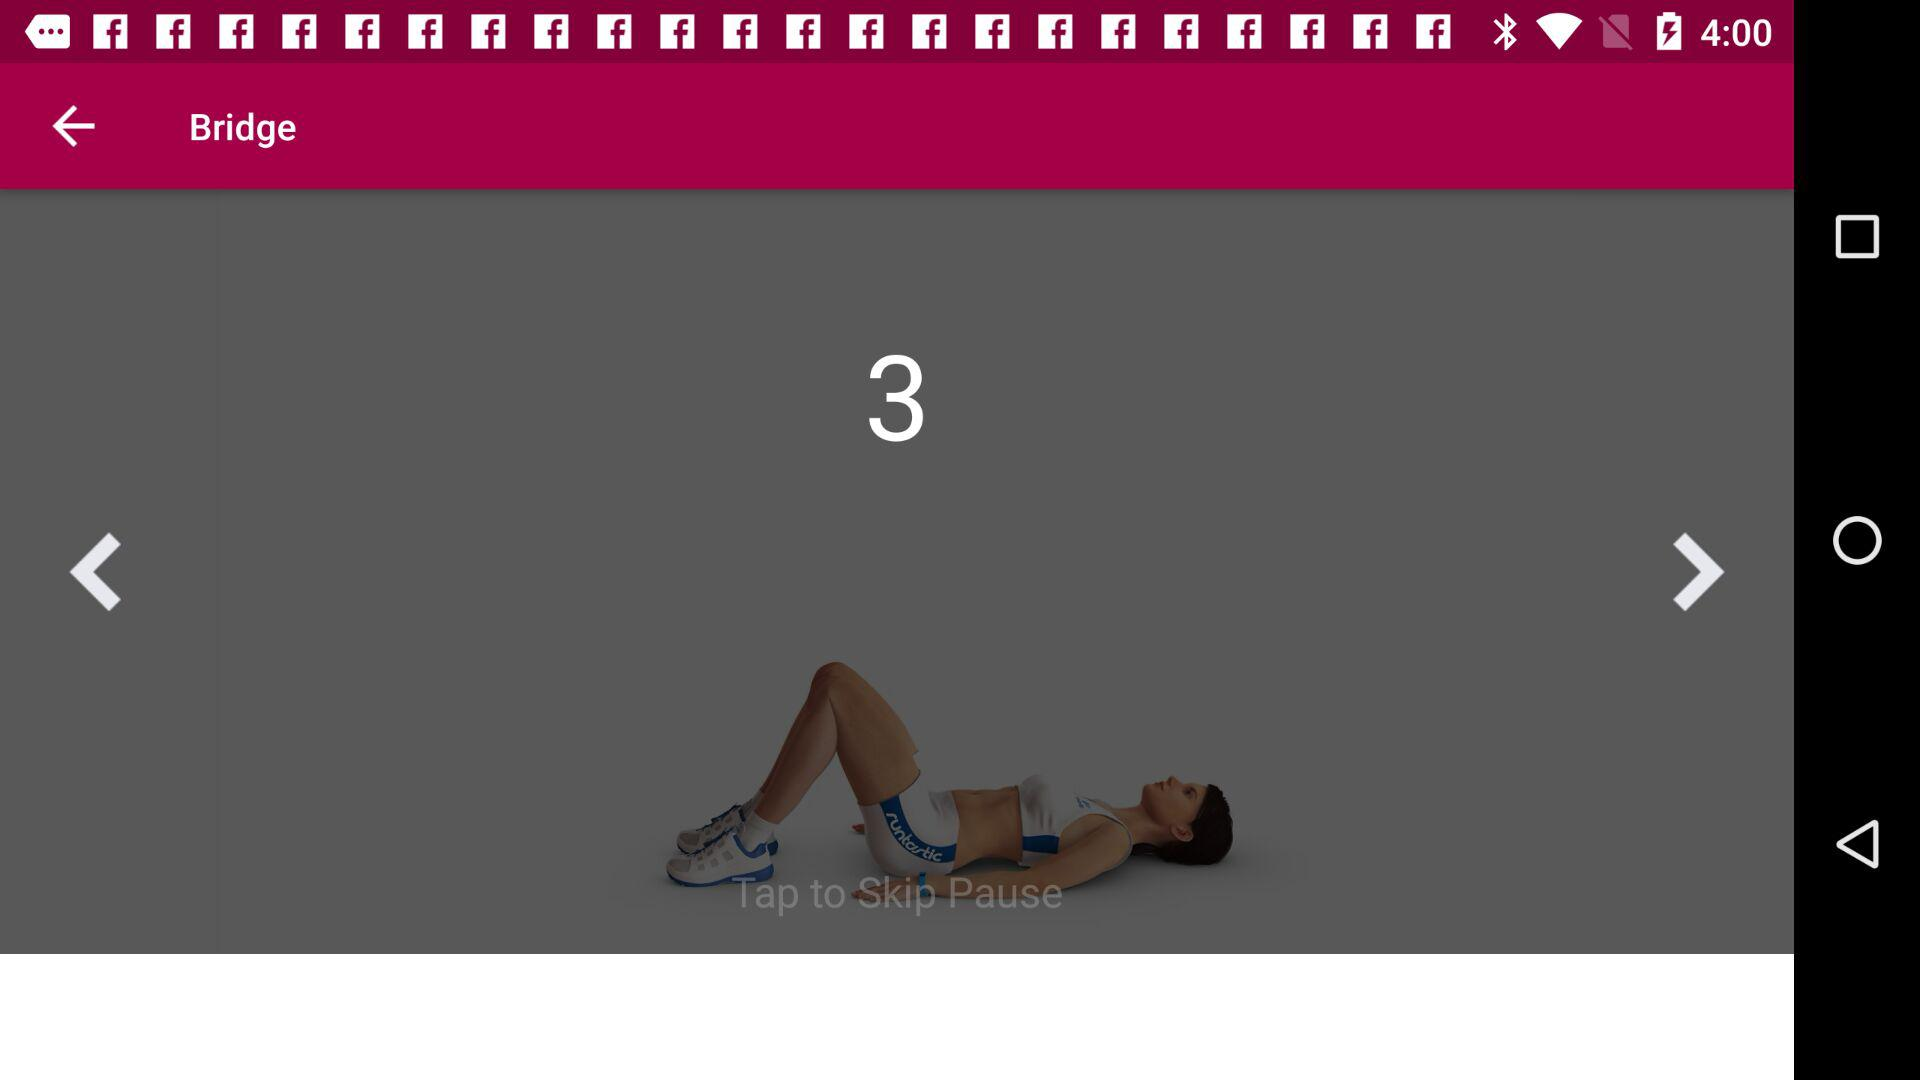What is the end date of Level 1? The end date is February 15, 2017. 